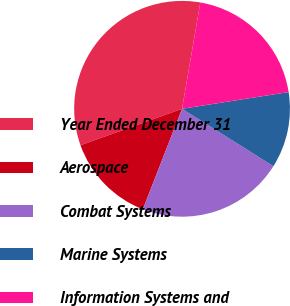<chart> <loc_0><loc_0><loc_500><loc_500><pie_chart><fcel>Year Ended December 31<fcel>Aerospace<fcel>Combat Systems<fcel>Marine Systems<fcel>Information Systems and<nl><fcel>33.2%<fcel>13.59%<fcel>21.99%<fcel>11.41%<fcel>19.81%<nl></chart> 